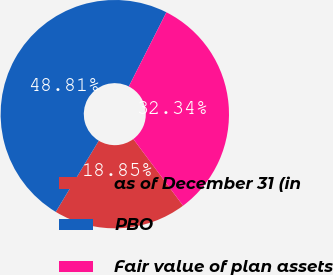<chart> <loc_0><loc_0><loc_500><loc_500><pie_chart><fcel>as of December 31 (in<fcel>PBO<fcel>Fair value of plan assets<nl><fcel>18.85%<fcel>48.81%<fcel>32.34%<nl></chart> 